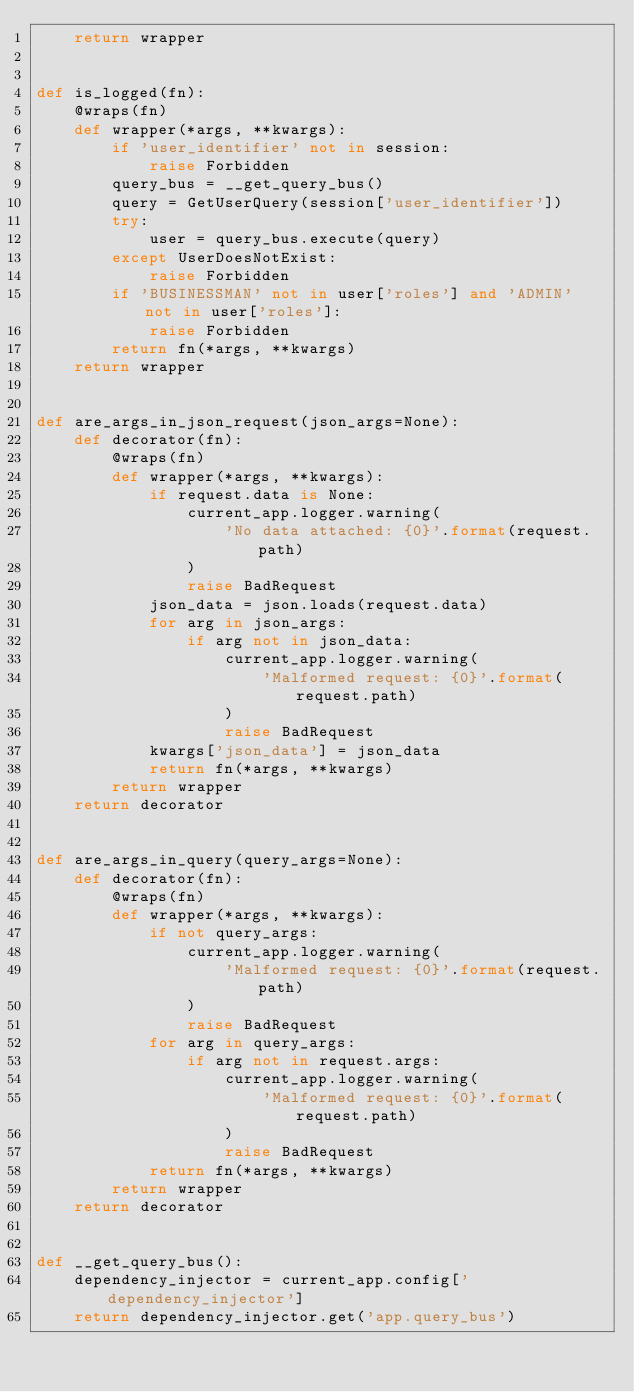<code> <loc_0><loc_0><loc_500><loc_500><_Python_>    return wrapper


def is_logged(fn):
    @wraps(fn)
    def wrapper(*args, **kwargs):
        if 'user_identifier' not in session:
            raise Forbidden
        query_bus = __get_query_bus()
        query = GetUserQuery(session['user_identifier'])
        try:
            user = query_bus.execute(query)
        except UserDoesNotExist:
            raise Forbidden
        if 'BUSINESSMAN' not in user['roles'] and 'ADMIN' not in user['roles']:
            raise Forbidden
        return fn(*args, **kwargs)
    return wrapper


def are_args_in_json_request(json_args=None):
    def decorator(fn):
        @wraps(fn)
        def wrapper(*args, **kwargs):
            if request.data is None:
                current_app.logger.warning(
                    'No data attached: {0}'.format(request.path)
                )
                raise BadRequest
            json_data = json.loads(request.data)
            for arg in json_args:
                if arg not in json_data:
                    current_app.logger.warning(
                        'Malformed request: {0}'.format(request.path)
                    )
                    raise BadRequest
            kwargs['json_data'] = json_data
            return fn(*args, **kwargs)
        return wrapper
    return decorator


def are_args_in_query(query_args=None):
    def decorator(fn):
        @wraps(fn)
        def wrapper(*args, **kwargs):
            if not query_args:
                current_app.logger.warning(
                    'Malformed request: {0}'.format(request.path)
                )
                raise BadRequest
            for arg in query_args:
                if arg not in request.args:
                    current_app.logger.warning(
                        'Malformed request: {0}'.format(request.path)
                    )
                    raise BadRequest
            return fn(*args, **kwargs)
        return wrapper
    return decorator


def __get_query_bus():
    dependency_injector = current_app.config['dependency_injector']
    return dependency_injector.get('app.query_bus')
</code> 